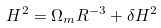<formula> <loc_0><loc_0><loc_500><loc_500>H ^ { 2 } = \Omega _ { m } R ^ { - 3 } + \delta H ^ { 2 }</formula> 